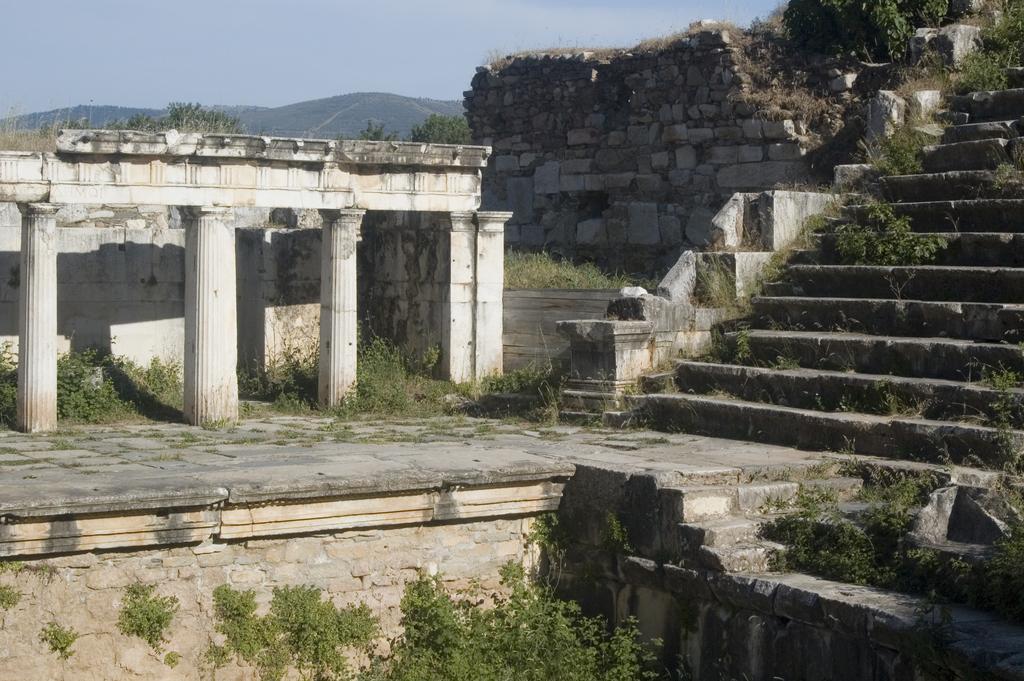Could you give a brief overview of what you see in this image? In the picture we can see some plants and behind it, we can see some old construction with pillars and beside it, we can see some steps and some plants on it and beside it, we can see a broken wall and in the background we can see the hill and the sky. 